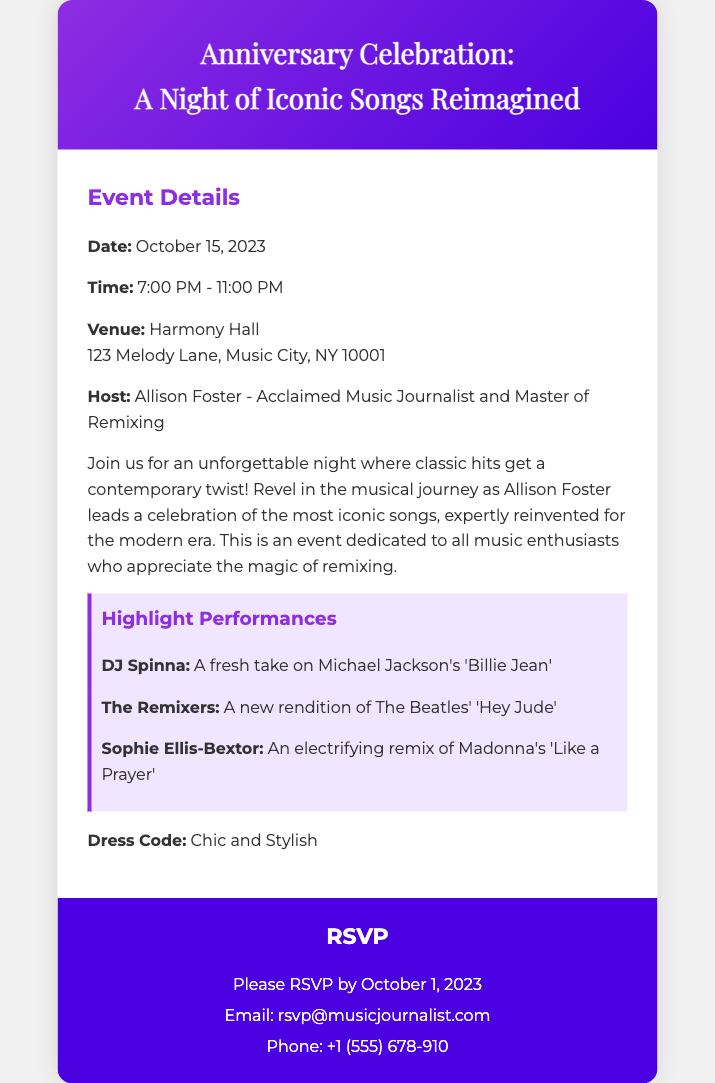what is the date of the event? The date is specified as October 15, 2023 in the event details section.
Answer: October 15, 2023 what time does the event start? The starting time of the event is mentioned as 7:00 PM in the document.
Answer: 7:00 PM who is hosting the event? The host is revealed to be Allison Foster, an acclaimed music journalist, according to the document.
Answer: Allison Foster what is the venue name? The venue name, as stated in the document, is Harmony Hall.
Answer: Harmony Hall what is the dress code for the event? The dress code is clearly outlined in the document as "Chic and Stylish."
Answer: Chic and Stylish how many highlight performances are listed? The document details three highlight performances, providing a count of the listed performances.
Answer: Three why is the event dedicated to music enthusiasts? The event highlights the magic of remixing iconic songs, which attracts dedicated music enthusiasts and is emphasized in the document.
Answer: Because of the magic of remixing when is the RSVP deadline? The RSVP deadline is indicated as October 1, 2023 in the RSVP section.
Answer: October 1, 2023 what type of event is this document about? The document pertains to an anniversary celebration focused on iconic songs reimagined, as indicated in the title.
Answer: Anniversary Celebration: A Night of Iconic Songs Reimagined 